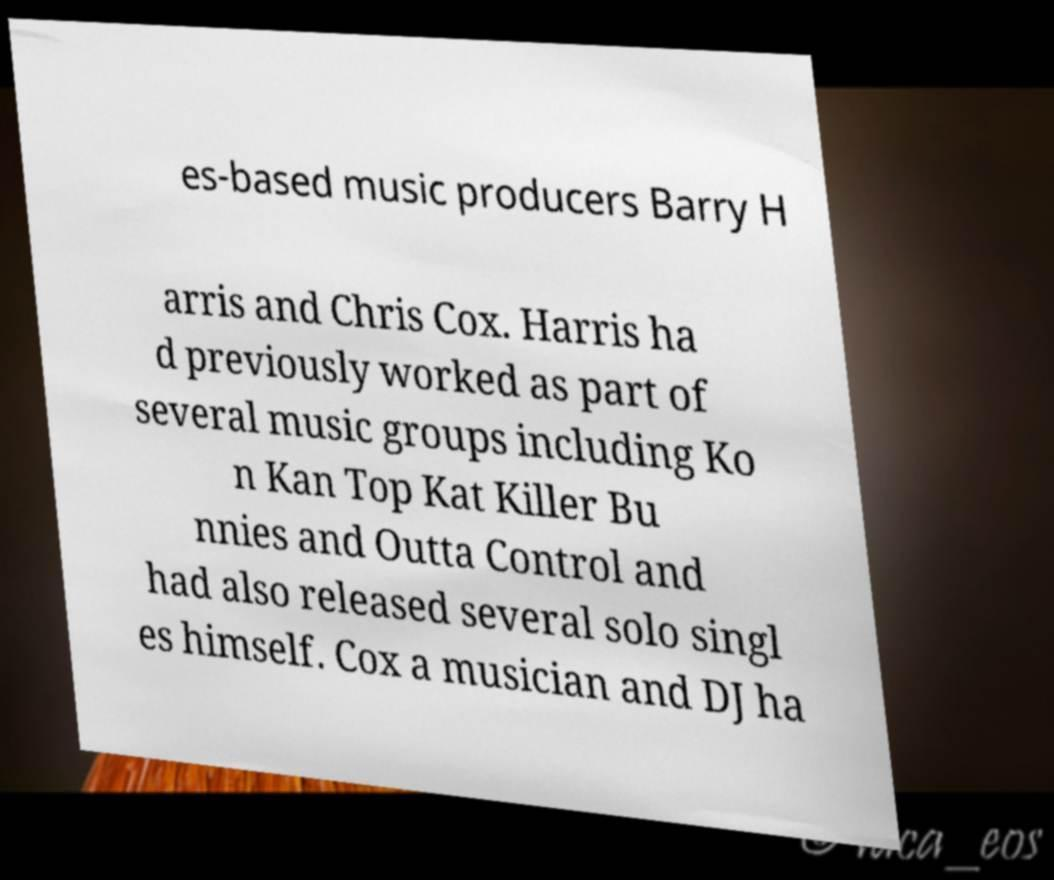I need the written content from this picture converted into text. Can you do that? es-based music producers Barry H arris and Chris Cox. Harris ha d previously worked as part of several music groups including Ko n Kan Top Kat Killer Bu nnies and Outta Control and had also released several solo singl es himself. Cox a musician and DJ ha 